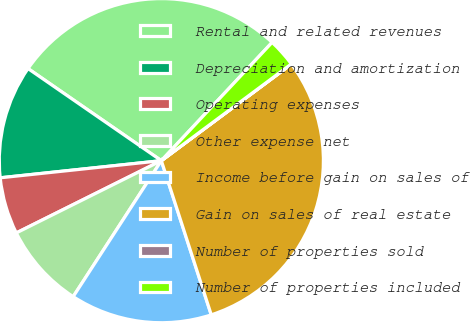<chart> <loc_0><loc_0><loc_500><loc_500><pie_chart><fcel>Rental and related revenues<fcel>Depreciation and amortization<fcel>Operating expenses<fcel>Other expense net<fcel>Income before gain on sales of<fcel>Gain on sales of real estate<fcel>Number of properties sold<fcel>Number of properties included<nl><fcel>27.36%<fcel>11.31%<fcel>5.67%<fcel>8.49%<fcel>14.14%<fcel>30.18%<fcel>0.02%<fcel>2.84%<nl></chart> 